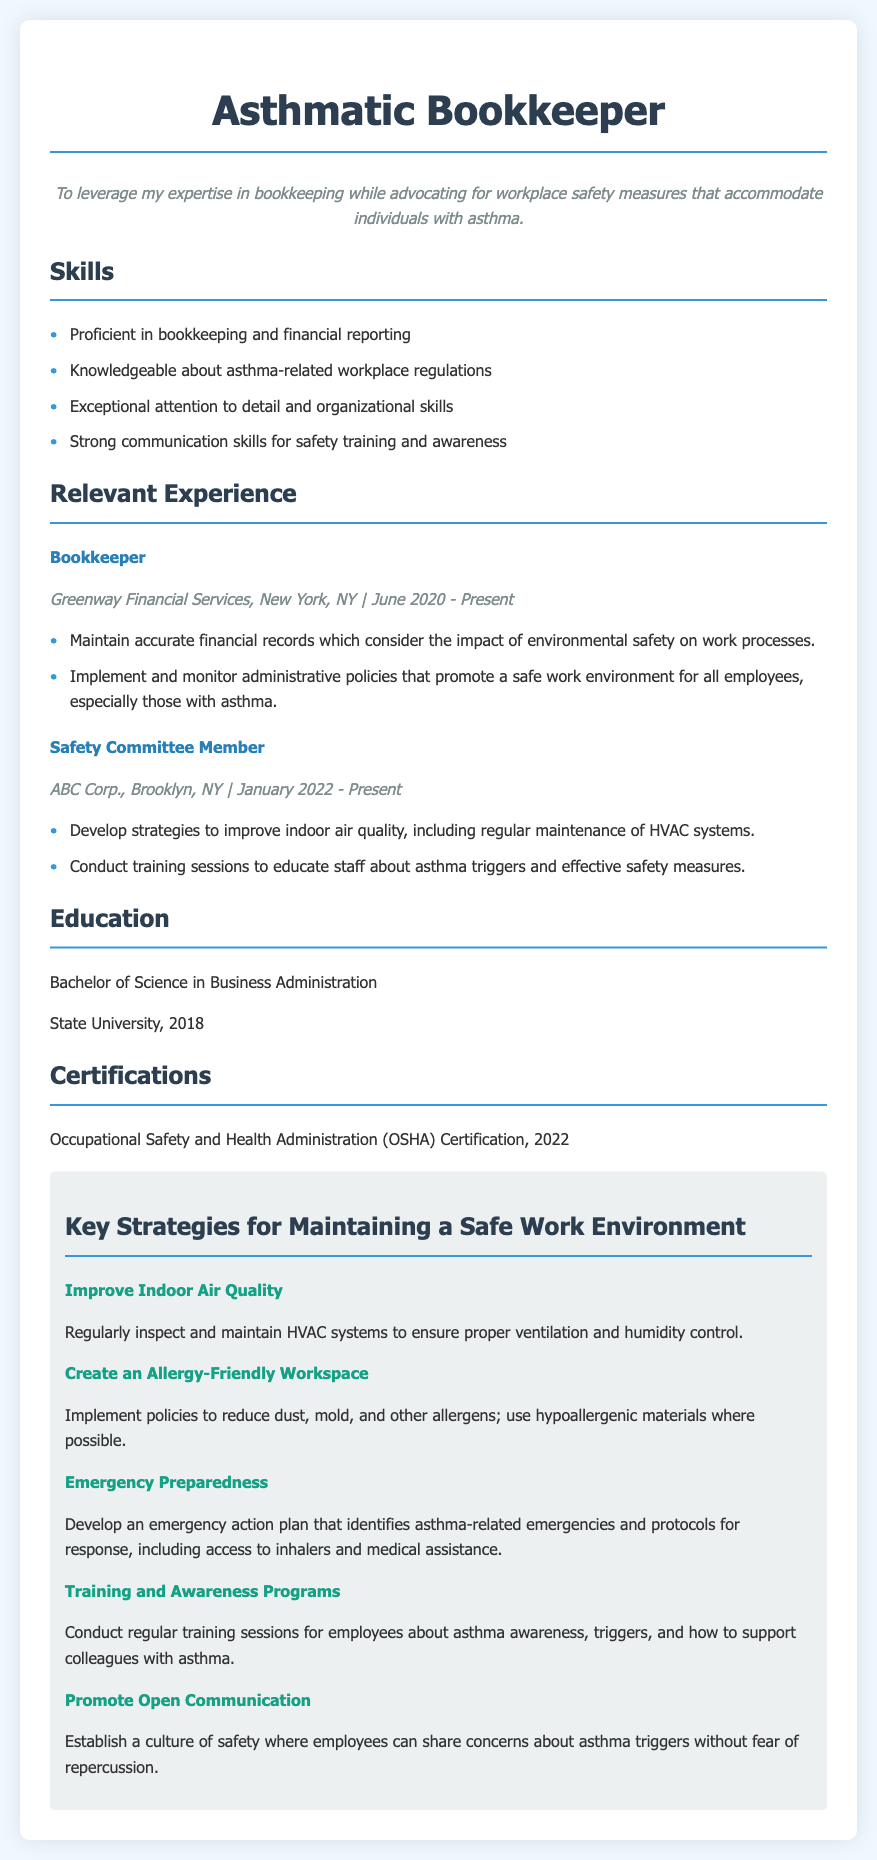what is the current job title of the individual? The individual's current job title listed in the document is Bookkeeper.
Answer: Bookkeeper what year did the individual graduate? The document states the year of graduation is 2018.
Answer: 2018 how many strategies are listed for maintaining a safe work environment? There are five strategies listed in the strategies section of the document.
Answer: Five which company does the individual work for? The document states that the individual works for Greenway Financial Services.
Answer: Greenway Financial Services what certification does the individual possess? The document lists OSHA Certification as the certification the individual has.
Answer: OSHA Certification what is one of the key strategies for maintaining a safe work environment? The document includes several key strategies; one of them is to improve indoor air quality.
Answer: Improve Indoor Air Quality what type of workplace training does the individual conduct? The individual conducts training sessions about asthma awareness and triggers as indicated in the document.
Answer: Asthma awareness training what is emphasized in the "Promote Open Communication" strategy? The strategy emphasizes establishing a culture of safety for sharing concerns without fear of repercussion.
Answer: Establishing a culture of safety how long has the individual been a member of the Safety Committee? The document states that the individual has been a member since January 2022, making it around two years.
Answer: Around two years 